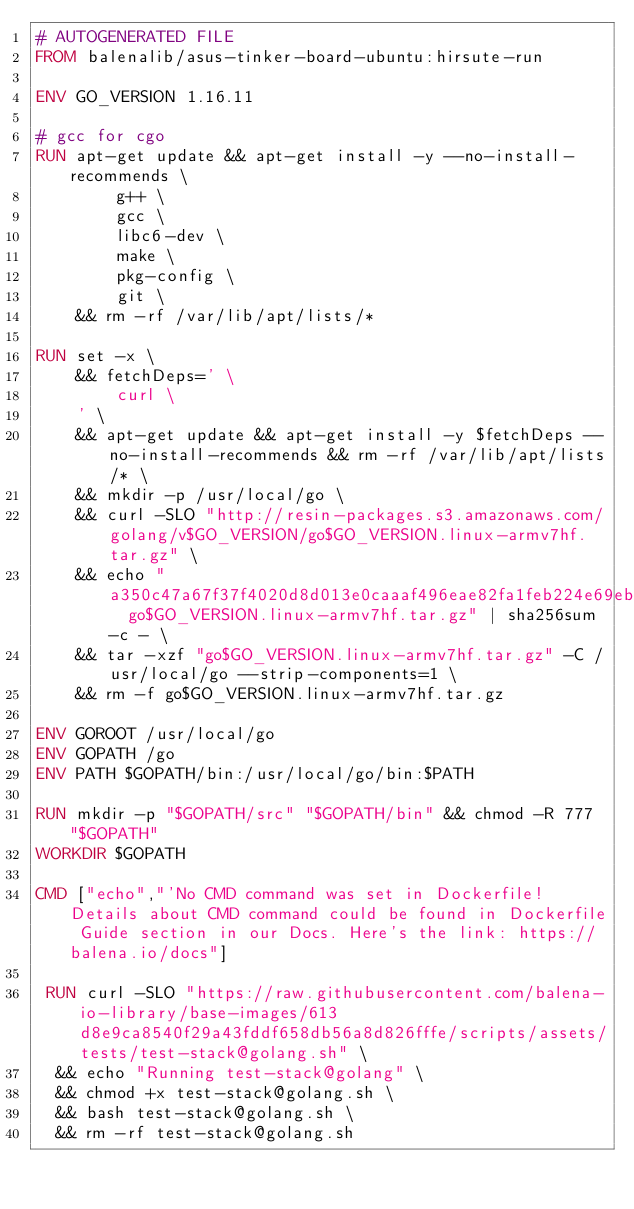Convert code to text. <code><loc_0><loc_0><loc_500><loc_500><_Dockerfile_># AUTOGENERATED FILE
FROM balenalib/asus-tinker-board-ubuntu:hirsute-run

ENV GO_VERSION 1.16.11

# gcc for cgo
RUN apt-get update && apt-get install -y --no-install-recommends \
		g++ \
		gcc \
		libc6-dev \
		make \
		pkg-config \
		git \
	&& rm -rf /var/lib/apt/lists/*

RUN set -x \
	&& fetchDeps=' \
		curl \
	' \
	&& apt-get update && apt-get install -y $fetchDeps --no-install-recommends && rm -rf /var/lib/apt/lists/* \
	&& mkdir -p /usr/local/go \
	&& curl -SLO "http://resin-packages.s3.amazonaws.com/golang/v$GO_VERSION/go$GO_VERSION.linux-armv7hf.tar.gz" \
	&& echo "a350c47a67f37f4020d8d013e0caaaf496eae82fa1feb224e69eb98cc09878a6  go$GO_VERSION.linux-armv7hf.tar.gz" | sha256sum -c - \
	&& tar -xzf "go$GO_VERSION.linux-armv7hf.tar.gz" -C /usr/local/go --strip-components=1 \
	&& rm -f go$GO_VERSION.linux-armv7hf.tar.gz

ENV GOROOT /usr/local/go
ENV GOPATH /go
ENV PATH $GOPATH/bin:/usr/local/go/bin:$PATH

RUN mkdir -p "$GOPATH/src" "$GOPATH/bin" && chmod -R 777 "$GOPATH"
WORKDIR $GOPATH

CMD ["echo","'No CMD command was set in Dockerfile! Details about CMD command could be found in Dockerfile Guide section in our Docs. Here's the link: https://balena.io/docs"]

 RUN curl -SLO "https://raw.githubusercontent.com/balena-io-library/base-images/613d8e9ca8540f29a43fddf658db56a8d826fffe/scripts/assets/tests/test-stack@golang.sh" \
  && echo "Running test-stack@golang" \
  && chmod +x test-stack@golang.sh \
  && bash test-stack@golang.sh \
  && rm -rf test-stack@golang.sh 
</code> 